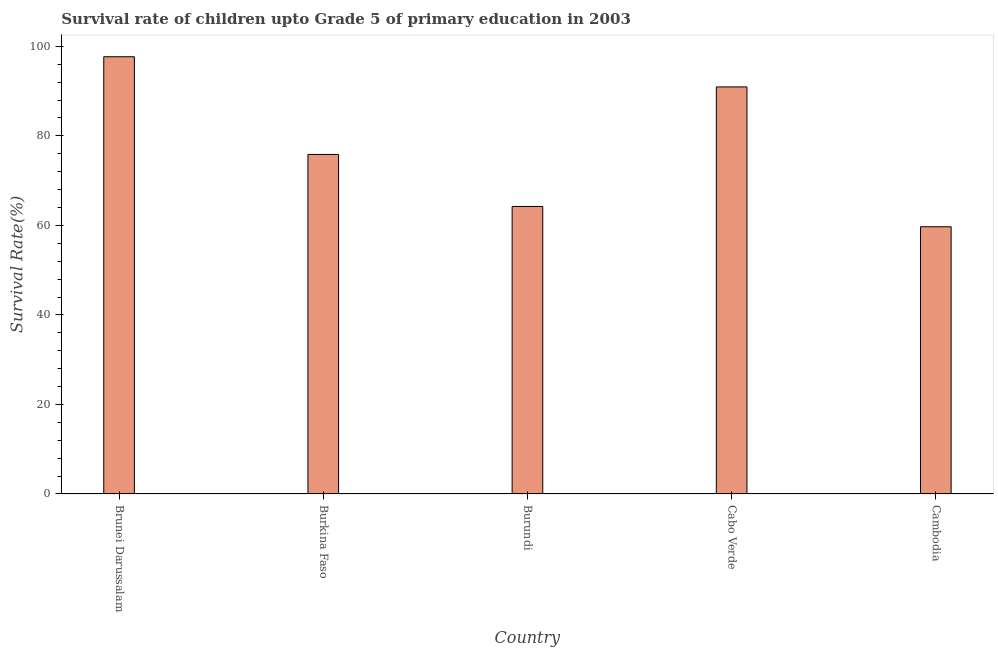What is the title of the graph?
Offer a terse response. Survival rate of children upto Grade 5 of primary education in 2003 . What is the label or title of the X-axis?
Ensure brevity in your answer.  Country. What is the label or title of the Y-axis?
Your response must be concise. Survival Rate(%). What is the survival rate in Cabo Verde?
Offer a terse response. 90.94. Across all countries, what is the maximum survival rate?
Ensure brevity in your answer.  97.68. Across all countries, what is the minimum survival rate?
Offer a very short reply. 59.7. In which country was the survival rate maximum?
Your response must be concise. Brunei Darussalam. In which country was the survival rate minimum?
Offer a very short reply. Cambodia. What is the sum of the survival rate?
Offer a very short reply. 388.41. What is the difference between the survival rate in Cabo Verde and Cambodia?
Ensure brevity in your answer.  31.24. What is the average survival rate per country?
Your answer should be compact. 77.68. What is the median survival rate?
Provide a short and direct response. 75.85. What is the ratio of the survival rate in Burkina Faso to that in Cambodia?
Your response must be concise. 1.27. Is the difference between the survival rate in Brunei Darussalam and Burundi greater than the difference between any two countries?
Keep it short and to the point. No. What is the difference between the highest and the second highest survival rate?
Provide a succinct answer. 6.74. Is the sum of the survival rate in Burkina Faso and Cabo Verde greater than the maximum survival rate across all countries?
Provide a succinct answer. Yes. What is the difference between the highest and the lowest survival rate?
Offer a very short reply. 37.98. In how many countries, is the survival rate greater than the average survival rate taken over all countries?
Give a very brief answer. 2. What is the Survival Rate(%) in Brunei Darussalam?
Keep it short and to the point. 97.68. What is the Survival Rate(%) of Burkina Faso?
Your answer should be very brief. 75.85. What is the Survival Rate(%) of Burundi?
Your response must be concise. 64.23. What is the Survival Rate(%) in Cabo Verde?
Provide a short and direct response. 90.94. What is the Survival Rate(%) of Cambodia?
Give a very brief answer. 59.7. What is the difference between the Survival Rate(%) in Brunei Darussalam and Burkina Faso?
Provide a short and direct response. 21.83. What is the difference between the Survival Rate(%) in Brunei Darussalam and Burundi?
Your answer should be very brief. 33.45. What is the difference between the Survival Rate(%) in Brunei Darussalam and Cabo Verde?
Your response must be concise. 6.74. What is the difference between the Survival Rate(%) in Brunei Darussalam and Cambodia?
Make the answer very short. 37.98. What is the difference between the Survival Rate(%) in Burkina Faso and Burundi?
Your answer should be very brief. 11.62. What is the difference between the Survival Rate(%) in Burkina Faso and Cabo Verde?
Make the answer very short. -15.09. What is the difference between the Survival Rate(%) in Burkina Faso and Cambodia?
Provide a succinct answer. 16.15. What is the difference between the Survival Rate(%) in Burundi and Cabo Verde?
Keep it short and to the point. -26.71. What is the difference between the Survival Rate(%) in Burundi and Cambodia?
Provide a short and direct response. 4.53. What is the difference between the Survival Rate(%) in Cabo Verde and Cambodia?
Give a very brief answer. 31.24. What is the ratio of the Survival Rate(%) in Brunei Darussalam to that in Burkina Faso?
Your answer should be compact. 1.29. What is the ratio of the Survival Rate(%) in Brunei Darussalam to that in Burundi?
Keep it short and to the point. 1.52. What is the ratio of the Survival Rate(%) in Brunei Darussalam to that in Cabo Verde?
Offer a very short reply. 1.07. What is the ratio of the Survival Rate(%) in Brunei Darussalam to that in Cambodia?
Your answer should be very brief. 1.64. What is the ratio of the Survival Rate(%) in Burkina Faso to that in Burundi?
Your answer should be compact. 1.18. What is the ratio of the Survival Rate(%) in Burkina Faso to that in Cabo Verde?
Offer a terse response. 0.83. What is the ratio of the Survival Rate(%) in Burkina Faso to that in Cambodia?
Provide a succinct answer. 1.27. What is the ratio of the Survival Rate(%) in Burundi to that in Cabo Verde?
Offer a terse response. 0.71. What is the ratio of the Survival Rate(%) in Burundi to that in Cambodia?
Your response must be concise. 1.08. What is the ratio of the Survival Rate(%) in Cabo Verde to that in Cambodia?
Ensure brevity in your answer.  1.52. 